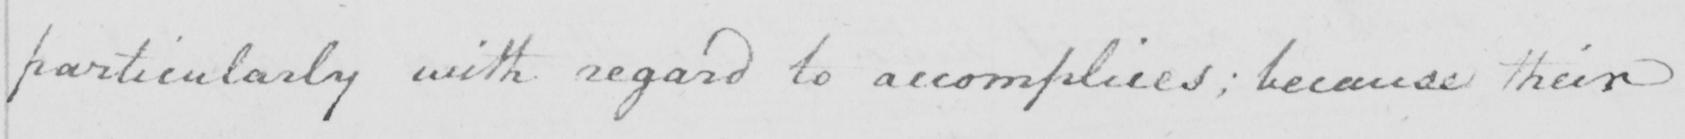Please transcribe the handwritten text in this image. particularly with regard to accomplices ; because their 